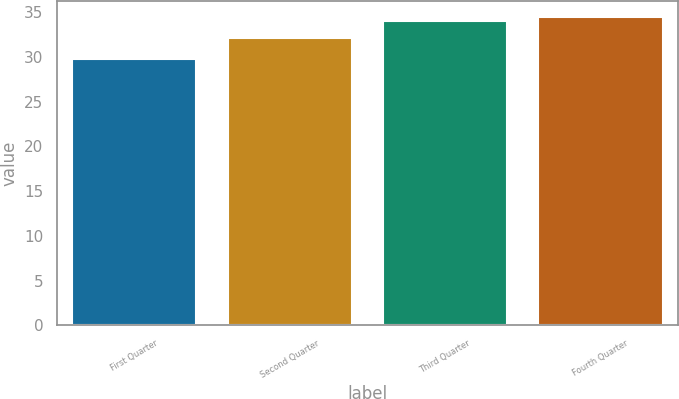<chart> <loc_0><loc_0><loc_500><loc_500><bar_chart><fcel>First Quarter<fcel>Second Quarter<fcel>Third Quarter<fcel>Fourth Quarter<nl><fcel>29.76<fcel>32.05<fcel>34.03<fcel>34.49<nl></chart> 